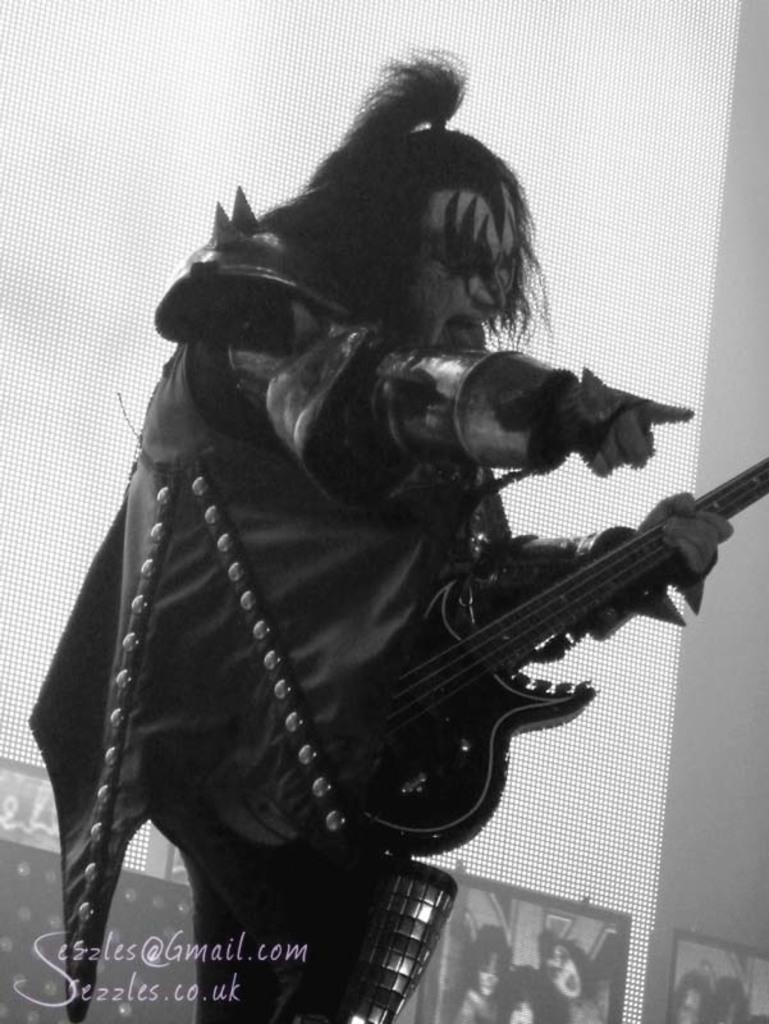Could you give a brief overview of what you see in this image? In this image there is a person standing and playing a guitar , and at the back ground there is a screen. 